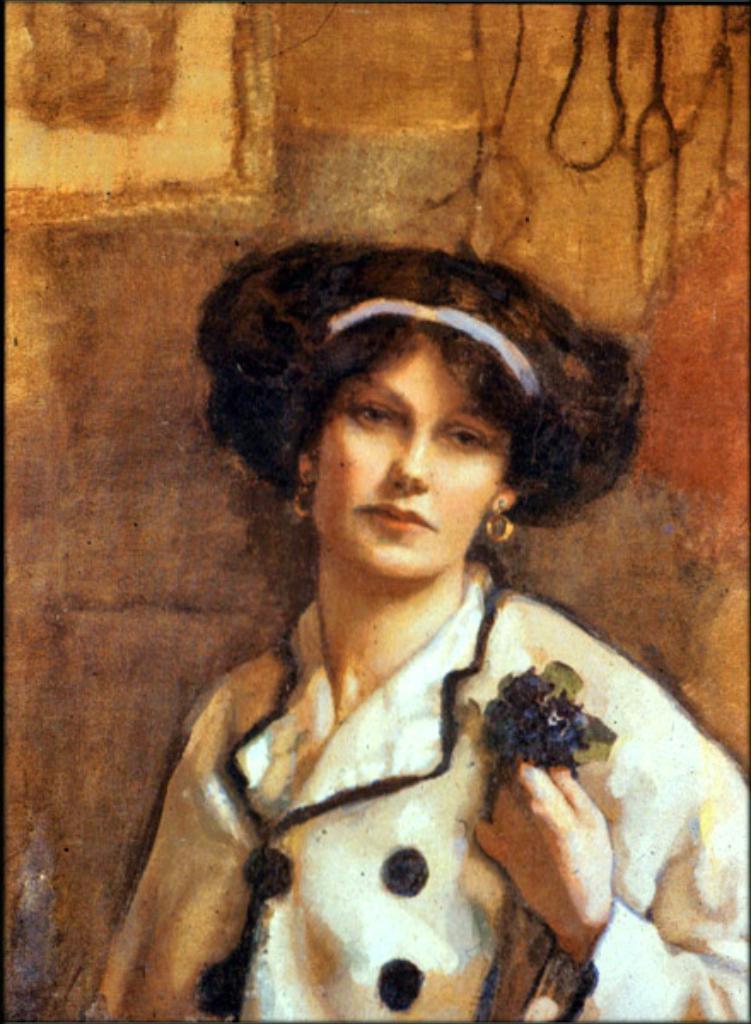Describe this image in one or two sentences. This image is an edited image. In the background there is a wall. In the middle of the image there is a woman. 